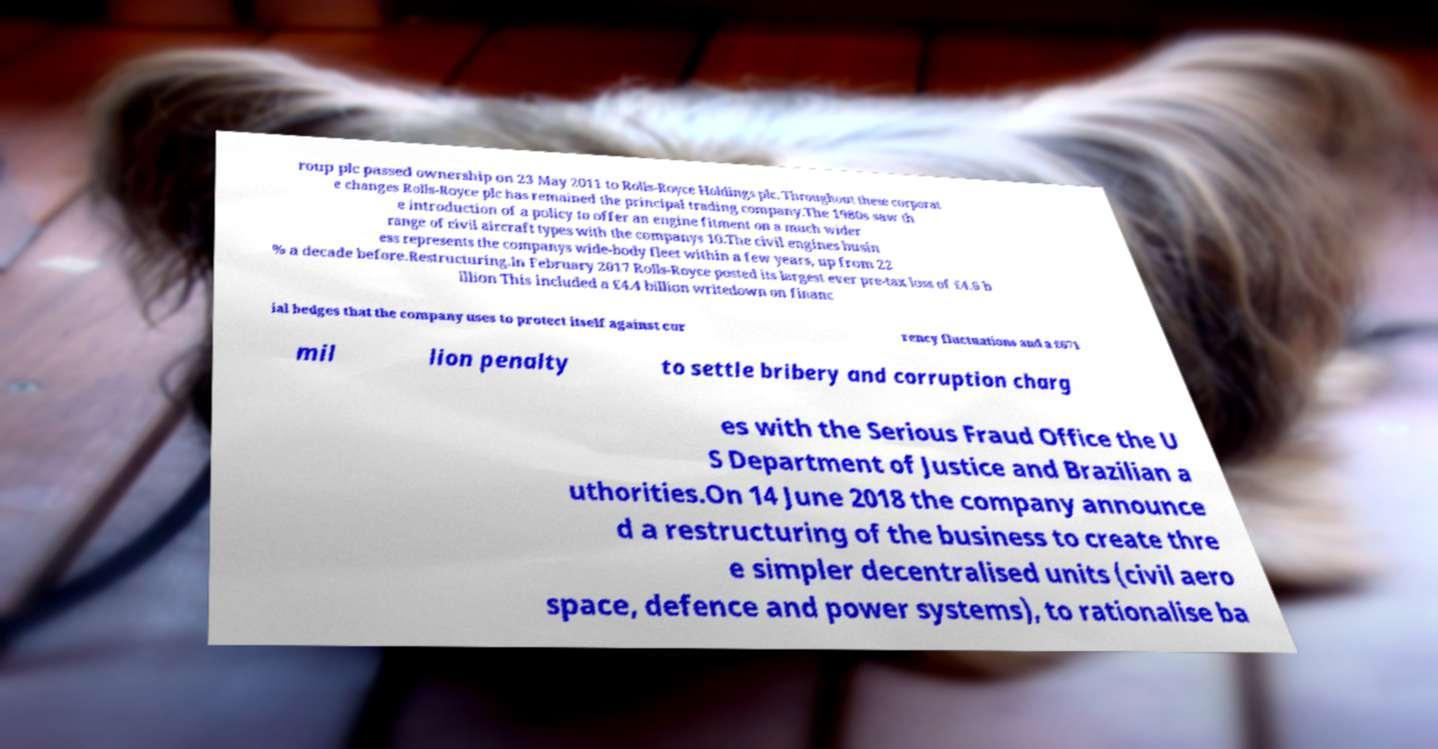Can you accurately transcribe the text from the provided image for me? roup plc passed ownership on 23 May 2011 to Rolls-Royce Holdings plc. Throughout these corporat e changes Rolls-Royce plc has remained the principal trading company.The 1980s saw th e introduction of a policy to offer an engine fitment on a much wider range of civil aircraft types with the companys 10.The civil engines busin ess represents the companys wide-body fleet within a few years, up from 22 % a decade before.Restructuring.In February 2017 Rolls-Royce posted its largest ever pre-tax loss of £4.6 b illion This included a £4.4 billion writedown on financ ial hedges that the company uses to protect itself against cur rency fluctuations and a £671 mil lion penalty to settle bribery and corruption charg es with the Serious Fraud Office the U S Department of Justice and Brazilian a uthorities.On 14 June 2018 the company announce d a restructuring of the business to create thre e simpler decentralised units (civil aero space, defence and power systems), to rationalise ba 